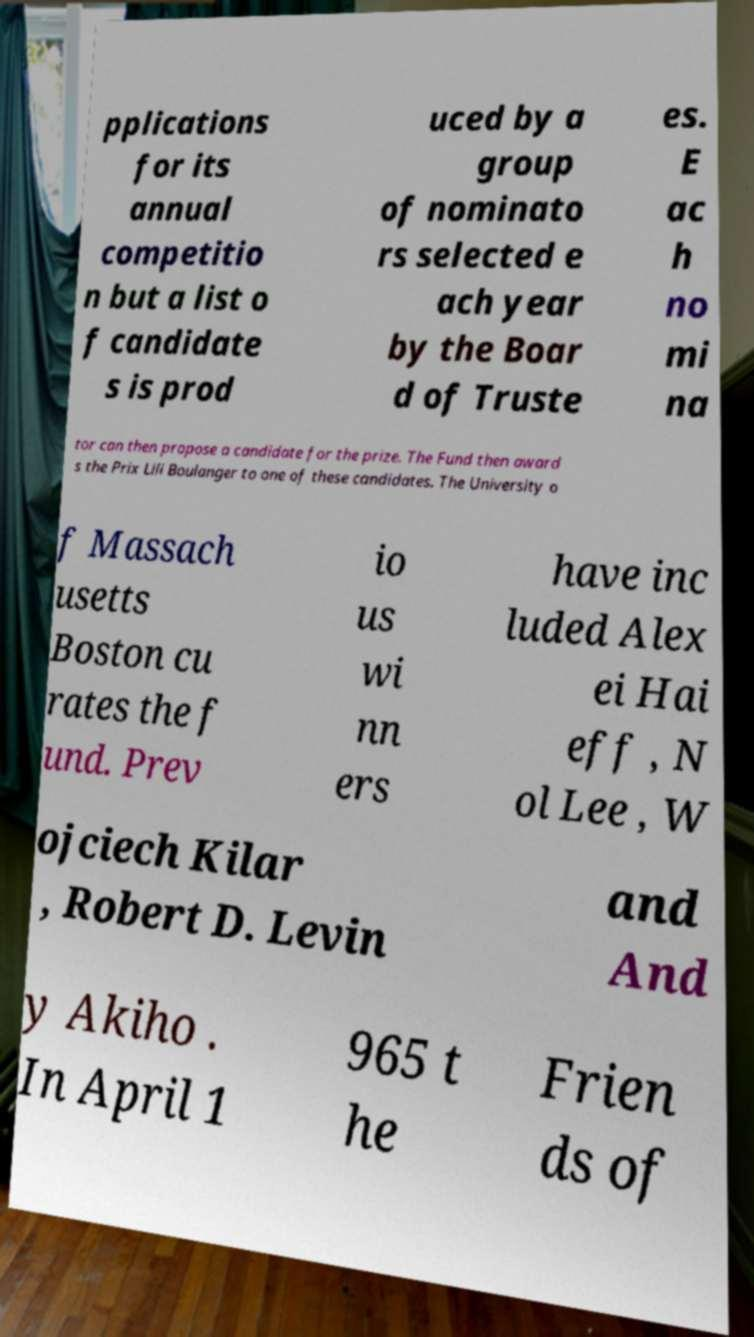Can you read and provide the text displayed in the image?This photo seems to have some interesting text. Can you extract and type it out for me? pplications for its annual competitio n but a list o f candidate s is prod uced by a group of nominato rs selected e ach year by the Boar d of Truste es. E ac h no mi na tor can then propose a candidate for the prize. The Fund then award s the Prix Lili Boulanger to one of these candidates. The University o f Massach usetts Boston cu rates the f und. Prev io us wi nn ers have inc luded Alex ei Hai eff , N ol Lee , W ojciech Kilar , Robert D. Levin and And y Akiho . In April 1 965 t he Frien ds of 